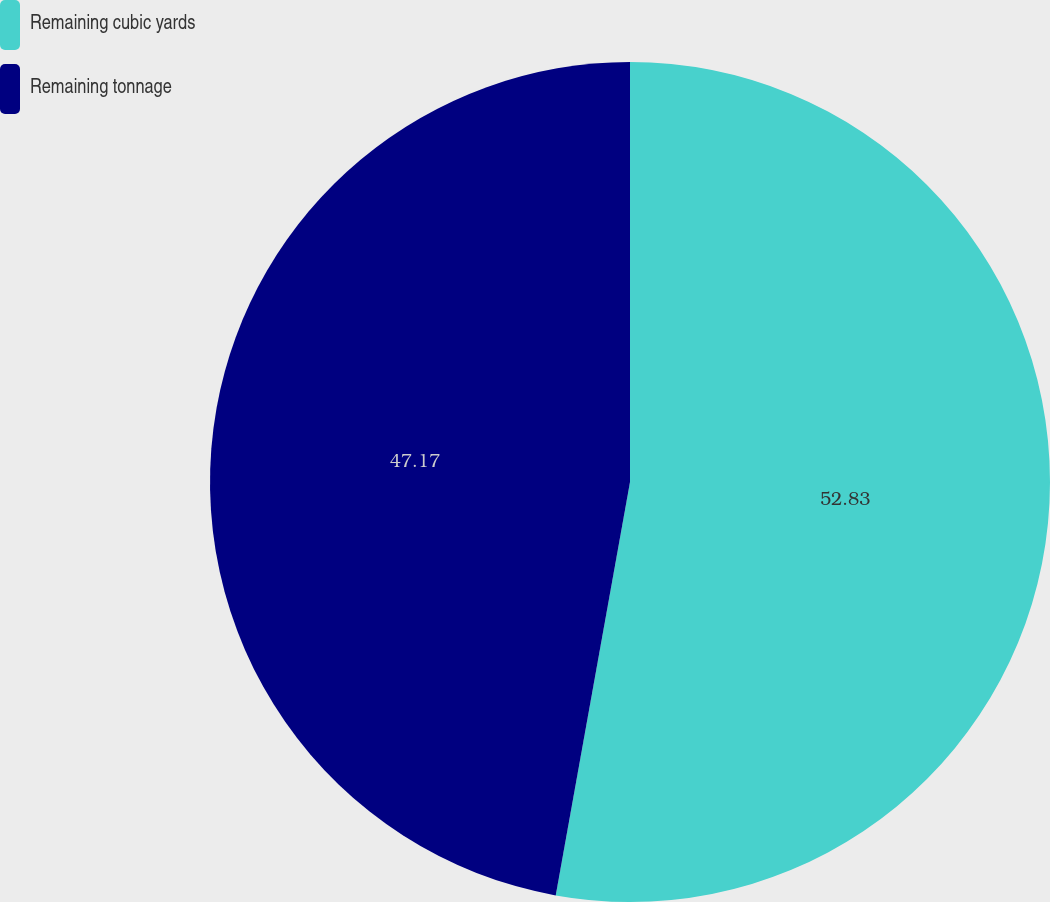<chart> <loc_0><loc_0><loc_500><loc_500><pie_chart><fcel>Remaining cubic yards<fcel>Remaining tonnage<nl><fcel>52.83%<fcel>47.17%<nl></chart> 